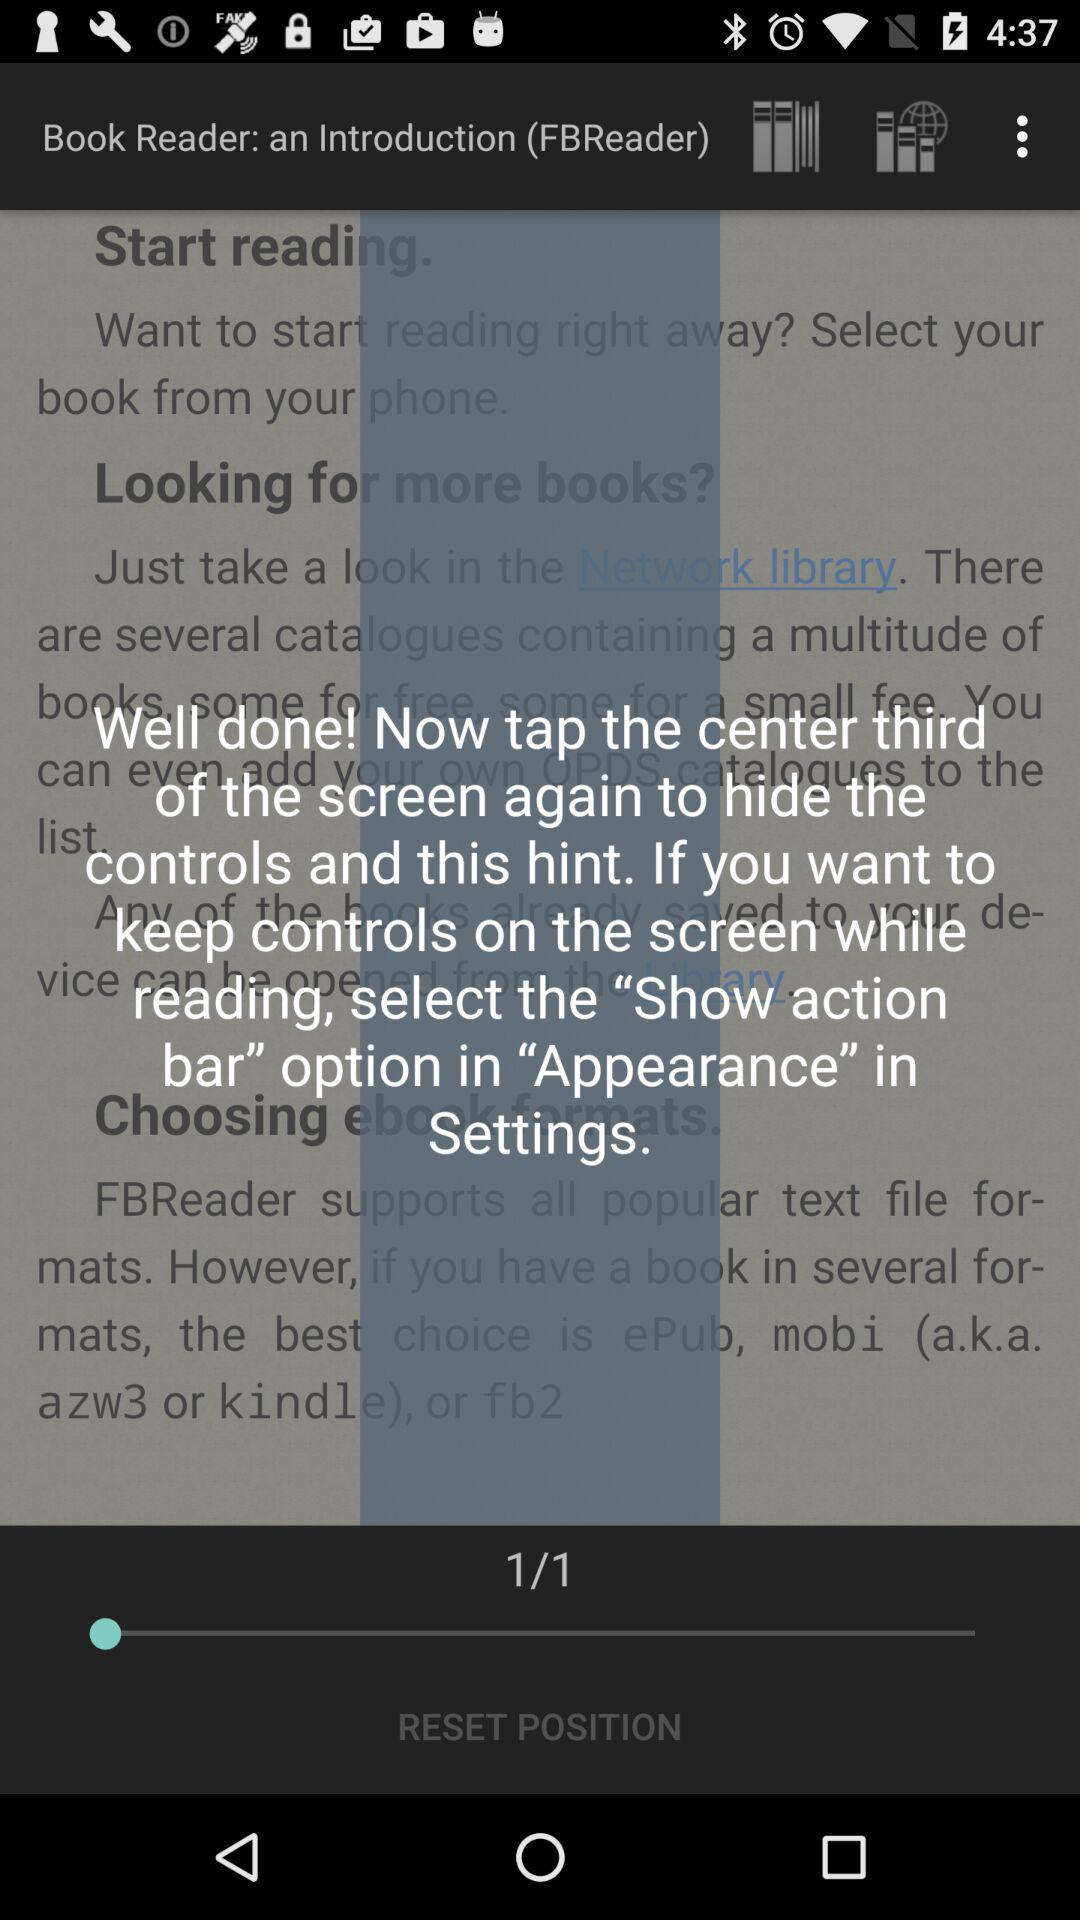What is the total number of pages? The total number of pages is 1. 